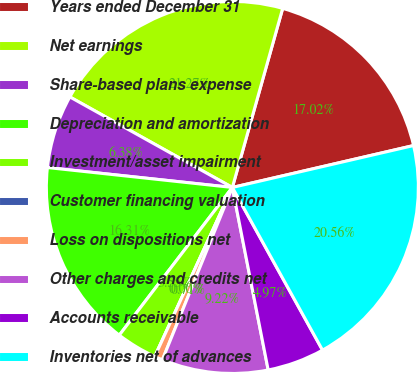Convert chart to OTSL. <chart><loc_0><loc_0><loc_500><loc_500><pie_chart><fcel>Years ended December 31<fcel>Net earnings<fcel>Share-based plans expense<fcel>Depreciation and amortization<fcel>Investment/asset impairment<fcel>Customer financing valuation<fcel>Loss on dispositions net<fcel>Other charges and credits net<fcel>Accounts receivable<fcel>Inventories net of advances<nl><fcel>17.02%<fcel>21.27%<fcel>6.38%<fcel>16.31%<fcel>3.55%<fcel>0.0%<fcel>0.71%<fcel>9.22%<fcel>4.97%<fcel>20.56%<nl></chart> 